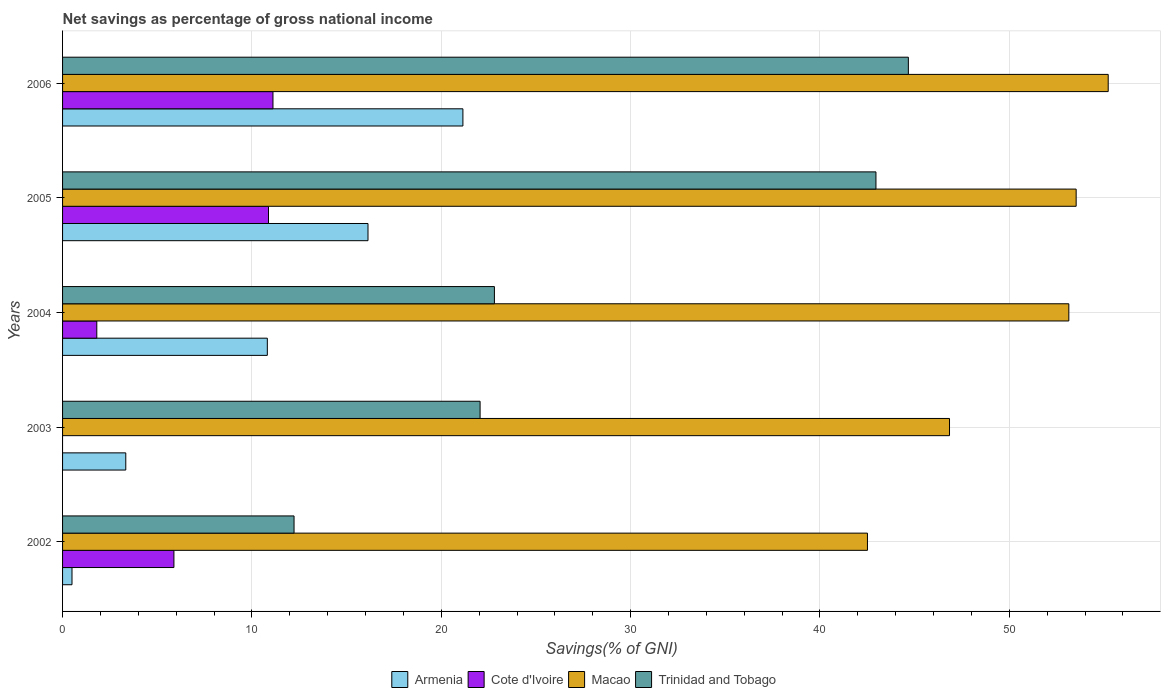How many different coloured bars are there?
Your answer should be compact. 4. How many groups of bars are there?
Provide a succinct answer. 5. Are the number of bars on each tick of the Y-axis equal?
Your answer should be very brief. No. What is the total savings in Cote d'Ivoire in 2002?
Ensure brevity in your answer.  5.88. Across all years, what is the maximum total savings in Cote d'Ivoire?
Your answer should be compact. 11.11. Across all years, what is the minimum total savings in Macao?
Ensure brevity in your answer.  42.51. In which year was the total savings in Armenia maximum?
Your response must be concise. 2006. What is the total total savings in Macao in the graph?
Ensure brevity in your answer.  251.24. What is the difference between the total savings in Armenia in 2005 and that in 2006?
Your answer should be very brief. -5.01. What is the difference between the total savings in Trinidad and Tobago in 2006 and the total savings in Armenia in 2002?
Your response must be concise. 44.17. What is the average total savings in Cote d'Ivoire per year?
Your response must be concise. 5.94. In the year 2005, what is the difference between the total savings in Armenia and total savings in Cote d'Ivoire?
Ensure brevity in your answer.  5.25. In how many years, is the total savings in Macao greater than 48 %?
Keep it short and to the point. 3. What is the ratio of the total savings in Armenia in 2002 to that in 2006?
Ensure brevity in your answer.  0.02. What is the difference between the highest and the second highest total savings in Cote d'Ivoire?
Keep it short and to the point. 0.24. What is the difference between the highest and the lowest total savings in Trinidad and Tobago?
Offer a very short reply. 32.44. Is the sum of the total savings in Macao in 2003 and 2004 greater than the maximum total savings in Cote d'Ivoire across all years?
Make the answer very short. Yes. How many years are there in the graph?
Provide a succinct answer. 5. What is the difference between two consecutive major ticks on the X-axis?
Offer a very short reply. 10. Are the values on the major ticks of X-axis written in scientific E-notation?
Provide a succinct answer. No. Does the graph contain any zero values?
Your answer should be very brief. Yes. Does the graph contain grids?
Your response must be concise. Yes. How many legend labels are there?
Your answer should be compact. 4. How are the legend labels stacked?
Your answer should be compact. Horizontal. What is the title of the graph?
Your answer should be very brief. Net savings as percentage of gross national income. What is the label or title of the X-axis?
Your answer should be compact. Savings(% of GNI). What is the label or title of the Y-axis?
Offer a terse response. Years. What is the Savings(% of GNI) of Armenia in 2002?
Your answer should be compact. 0.5. What is the Savings(% of GNI) of Cote d'Ivoire in 2002?
Offer a terse response. 5.88. What is the Savings(% of GNI) of Macao in 2002?
Offer a terse response. 42.51. What is the Savings(% of GNI) in Trinidad and Tobago in 2002?
Your answer should be very brief. 12.22. What is the Savings(% of GNI) in Armenia in 2003?
Make the answer very short. 3.34. What is the Savings(% of GNI) of Macao in 2003?
Give a very brief answer. 46.84. What is the Savings(% of GNI) of Trinidad and Tobago in 2003?
Your answer should be very brief. 22.05. What is the Savings(% of GNI) of Armenia in 2004?
Ensure brevity in your answer.  10.81. What is the Savings(% of GNI) of Cote d'Ivoire in 2004?
Give a very brief answer. 1.81. What is the Savings(% of GNI) of Macao in 2004?
Provide a succinct answer. 53.14. What is the Savings(% of GNI) in Trinidad and Tobago in 2004?
Provide a short and direct response. 22.81. What is the Savings(% of GNI) of Armenia in 2005?
Provide a succinct answer. 16.13. What is the Savings(% of GNI) of Cote d'Ivoire in 2005?
Offer a terse response. 10.88. What is the Savings(% of GNI) in Macao in 2005?
Ensure brevity in your answer.  53.53. What is the Savings(% of GNI) in Trinidad and Tobago in 2005?
Provide a short and direct response. 42.96. What is the Savings(% of GNI) in Armenia in 2006?
Keep it short and to the point. 21.14. What is the Savings(% of GNI) in Cote d'Ivoire in 2006?
Provide a short and direct response. 11.11. What is the Savings(% of GNI) in Macao in 2006?
Provide a succinct answer. 55.22. What is the Savings(% of GNI) of Trinidad and Tobago in 2006?
Give a very brief answer. 44.67. Across all years, what is the maximum Savings(% of GNI) in Armenia?
Offer a terse response. 21.14. Across all years, what is the maximum Savings(% of GNI) of Cote d'Ivoire?
Provide a short and direct response. 11.11. Across all years, what is the maximum Savings(% of GNI) of Macao?
Your response must be concise. 55.22. Across all years, what is the maximum Savings(% of GNI) of Trinidad and Tobago?
Your answer should be compact. 44.67. Across all years, what is the minimum Savings(% of GNI) of Armenia?
Offer a very short reply. 0.5. Across all years, what is the minimum Savings(% of GNI) in Cote d'Ivoire?
Provide a short and direct response. 0. Across all years, what is the minimum Savings(% of GNI) in Macao?
Provide a succinct answer. 42.51. Across all years, what is the minimum Savings(% of GNI) in Trinidad and Tobago?
Give a very brief answer. 12.22. What is the total Savings(% of GNI) of Armenia in the graph?
Provide a succinct answer. 51.92. What is the total Savings(% of GNI) in Cote d'Ivoire in the graph?
Your answer should be very brief. 29.68. What is the total Savings(% of GNI) in Macao in the graph?
Offer a terse response. 251.24. What is the total Savings(% of GNI) of Trinidad and Tobago in the graph?
Your response must be concise. 144.7. What is the difference between the Savings(% of GNI) of Armenia in 2002 and that in 2003?
Offer a terse response. -2.84. What is the difference between the Savings(% of GNI) of Macao in 2002 and that in 2003?
Make the answer very short. -4.33. What is the difference between the Savings(% of GNI) of Trinidad and Tobago in 2002 and that in 2003?
Make the answer very short. -9.83. What is the difference between the Savings(% of GNI) of Armenia in 2002 and that in 2004?
Provide a succinct answer. -10.32. What is the difference between the Savings(% of GNI) of Cote d'Ivoire in 2002 and that in 2004?
Provide a succinct answer. 4.07. What is the difference between the Savings(% of GNI) in Macao in 2002 and that in 2004?
Keep it short and to the point. -10.63. What is the difference between the Savings(% of GNI) of Trinidad and Tobago in 2002 and that in 2004?
Your answer should be compact. -10.58. What is the difference between the Savings(% of GNI) in Armenia in 2002 and that in 2005?
Offer a terse response. -15.63. What is the difference between the Savings(% of GNI) in Cote d'Ivoire in 2002 and that in 2005?
Offer a very short reply. -4.99. What is the difference between the Savings(% of GNI) of Macao in 2002 and that in 2005?
Your answer should be very brief. -11.02. What is the difference between the Savings(% of GNI) in Trinidad and Tobago in 2002 and that in 2005?
Your answer should be very brief. -30.73. What is the difference between the Savings(% of GNI) in Armenia in 2002 and that in 2006?
Provide a short and direct response. -20.64. What is the difference between the Savings(% of GNI) of Cote d'Ivoire in 2002 and that in 2006?
Make the answer very short. -5.23. What is the difference between the Savings(% of GNI) of Macao in 2002 and that in 2006?
Offer a very short reply. -12.71. What is the difference between the Savings(% of GNI) of Trinidad and Tobago in 2002 and that in 2006?
Offer a terse response. -32.44. What is the difference between the Savings(% of GNI) in Armenia in 2003 and that in 2004?
Provide a succinct answer. -7.48. What is the difference between the Savings(% of GNI) in Macao in 2003 and that in 2004?
Provide a short and direct response. -6.3. What is the difference between the Savings(% of GNI) of Trinidad and Tobago in 2003 and that in 2004?
Offer a terse response. -0.76. What is the difference between the Savings(% of GNI) of Armenia in 2003 and that in 2005?
Make the answer very short. -12.79. What is the difference between the Savings(% of GNI) in Macao in 2003 and that in 2005?
Your answer should be very brief. -6.69. What is the difference between the Savings(% of GNI) of Trinidad and Tobago in 2003 and that in 2005?
Your answer should be compact. -20.91. What is the difference between the Savings(% of GNI) in Armenia in 2003 and that in 2006?
Your answer should be compact. -17.8. What is the difference between the Savings(% of GNI) of Macao in 2003 and that in 2006?
Your response must be concise. -8.38. What is the difference between the Savings(% of GNI) in Trinidad and Tobago in 2003 and that in 2006?
Your answer should be compact. -22.62. What is the difference between the Savings(% of GNI) in Armenia in 2004 and that in 2005?
Give a very brief answer. -5.32. What is the difference between the Savings(% of GNI) in Cote d'Ivoire in 2004 and that in 2005?
Offer a very short reply. -9.07. What is the difference between the Savings(% of GNI) of Macao in 2004 and that in 2005?
Offer a terse response. -0.39. What is the difference between the Savings(% of GNI) of Trinidad and Tobago in 2004 and that in 2005?
Keep it short and to the point. -20.15. What is the difference between the Savings(% of GNI) of Armenia in 2004 and that in 2006?
Your answer should be compact. -10.33. What is the difference between the Savings(% of GNI) of Cote d'Ivoire in 2004 and that in 2006?
Give a very brief answer. -9.3. What is the difference between the Savings(% of GNI) in Macao in 2004 and that in 2006?
Ensure brevity in your answer.  -2.08. What is the difference between the Savings(% of GNI) in Trinidad and Tobago in 2004 and that in 2006?
Provide a succinct answer. -21.86. What is the difference between the Savings(% of GNI) of Armenia in 2005 and that in 2006?
Your answer should be compact. -5.01. What is the difference between the Savings(% of GNI) in Cote d'Ivoire in 2005 and that in 2006?
Your answer should be compact. -0.24. What is the difference between the Savings(% of GNI) in Macao in 2005 and that in 2006?
Ensure brevity in your answer.  -1.69. What is the difference between the Savings(% of GNI) in Trinidad and Tobago in 2005 and that in 2006?
Your answer should be very brief. -1.71. What is the difference between the Savings(% of GNI) in Armenia in 2002 and the Savings(% of GNI) in Macao in 2003?
Your answer should be very brief. -46.34. What is the difference between the Savings(% of GNI) in Armenia in 2002 and the Savings(% of GNI) in Trinidad and Tobago in 2003?
Make the answer very short. -21.55. What is the difference between the Savings(% of GNI) of Cote d'Ivoire in 2002 and the Savings(% of GNI) of Macao in 2003?
Keep it short and to the point. -40.96. What is the difference between the Savings(% of GNI) in Cote d'Ivoire in 2002 and the Savings(% of GNI) in Trinidad and Tobago in 2003?
Offer a very short reply. -16.17. What is the difference between the Savings(% of GNI) in Macao in 2002 and the Savings(% of GNI) in Trinidad and Tobago in 2003?
Give a very brief answer. 20.46. What is the difference between the Savings(% of GNI) in Armenia in 2002 and the Savings(% of GNI) in Cote d'Ivoire in 2004?
Offer a terse response. -1.31. What is the difference between the Savings(% of GNI) in Armenia in 2002 and the Savings(% of GNI) in Macao in 2004?
Provide a succinct answer. -52.64. What is the difference between the Savings(% of GNI) in Armenia in 2002 and the Savings(% of GNI) in Trinidad and Tobago in 2004?
Your response must be concise. -22.31. What is the difference between the Savings(% of GNI) in Cote d'Ivoire in 2002 and the Savings(% of GNI) in Macao in 2004?
Offer a terse response. -47.26. What is the difference between the Savings(% of GNI) in Cote d'Ivoire in 2002 and the Savings(% of GNI) in Trinidad and Tobago in 2004?
Your answer should be compact. -16.92. What is the difference between the Savings(% of GNI) in Macao in 2002 and the Savings(% of GNI) in Trinidad and Tobago in 2004?
Give a very brief answer. 19.7. What is the difference between the Savings(% of GNI) in Armenia in 2002 and the Savings(% of GNI) in Cote d'Ivoire in 2005?
Provide a succinct answer. -10.38. What is the difference between the Savings(% of GNI) of Armenia in 2002 and the Savings(% of GNI) of Macao in 2005?
Keep it short and to the point. -53.03. What is the difference between the Savings(% of GNI) of Armenia in 2002 and the Savings(% of GNI) of Trinidad and Tobago in 2005?
Provide a short and direct response. -42.46. What is the difference between the Savings(% of GNI) of Cote d'Ivoire in 2002 and the Savings(% of GNI) of Macao in 2005?
Your response must be concise. -47.65. What is the difference between the Savings(% of GNI) in Cote d'Ivoire in 2002 and the Savings(% of GNI) in Trinidad and Tobago in 2005?
Provide a short and direct response. -37.07. What is the difference between the Savings(% of GNI) in Macao in 2002 and the Savings(% of GNI) in Trinidad and Tobago in 2005?
Offer a terse response. -0.45. What is the difference between the Savings(% of GNI) of Armenia in 2002 and the Savings(% of GNI) of Cote d'Ivoire in 2006?
Give a very brief answer. -10.61. What is the difference between the Savings(% of GNI) in Armenia in 2002 and the Savings(% of GNI) in Macao in 2006?
Make the answer very short. -54.72. What is the difference between the Savings(% of GNI) in Armenia in 2002 and the Savings(% of GNI) in Trinidad and Tobago in 2006?
Make the answer very short. -44.17. What is the difference between the Savings(% of GNI) of Cote d'Ivoire in 2002 and the Savings(% of GNI) of Macao in 2006?
Ensure brevity in your answer.  -49.34. What is the difference between the Savings(% of GNI) in Cote d'Ivoire in 2002 and the Savings(% of GNI) in Trinidad and Tobago in 2006?
Offer a very short reply. -38.79. What is the difference between the Savings(% of GNI) in Macao in 2002 and the Savings(% of GNI) in Trinidad and Tobago in 2006?
Make the answer very short. -2.16. What is the difference between the Savings(% of GNI) in Armenia in 2003 and the Savings(% of GNI) in Cote d'Ivoire in 2004?
Offer a terse response. 1.53. What is the difference between the Savings(% of GNI) in Armenia in 2003 and the Savings(% of GNI) in Macao in 2004?
Your response must be concise. -49.8. What is the difference between the Savings(% of GNI) in Armenia in 2003 and the Savings(% of GNI) in Trinidad and Tobago in 2004?
Ensure brevity in your answer.  -19.47. What is the difference between the Savings(% of GNI) of Macao in 2003 and the Savings(% of GNI) of Trinidad and Tobago in 2004?
Ensure brevity in your answer.  24.04. What is the difference between the Savings(% of GNI) of Armenia in 2003 and the Savings(% of GNI) of Cote d'Ivoire in 2005?
Provide a short and direct response. -7.54. What is the difference between the Savings(% of GNI) in Armenia in 2003 and the Savings(% of GNI) in Macao in 2005?
Provide a succinct answer. -50.19. What is the difference between the Savings(% of GNI) of Armenia in 2003 and the Savings(% of GNI) of Trinidad and Tobago in 2005?
Provide a succinct answer. -39.62. What is the difference between the Savings(% of GNI) of Macao in 2003 and the Savings(% of GNI) of Trinidad and Tobago in 2005?
Make the answer very short. 3.89. What is the difference between the Savings(% of GNI) in Armenia in 2003 and the Savings(% of GNI) in Cote d'Ivoire in 2006?
Your answer should be compact. -7.77. What is the difference between the Savings(% of GNI) in Armenia in 2003 and the Savings(% of GNI) in Macao in 2006?
Keep it short and to the point. -51.88. What is the difference between the Savings(% of GNI) of Armenia in 2003 and the Savings(% of GNI) of Trinidad and Tobago in 2006?
Provide a succinct answer. -41.33. What is the difference between the Savings(% of GNI) in Macao in 2003 and the Savings(% of GNI) in Trinidad and Tobago in 2006?
Keep it short and to the point. 2.17. What is the difference between the Savings(% of GNI) in Armenia in 2004 and the Savings(% of GNI) in Cote d'Ivoire in 2005?
Keep it short and to the point. -0.06. What is the difference between the Savings(% of GNI) of Armenia in 2004 and the Savings(% of GNI) of Macao in 2005?
Give a very brief answer. -42.72. What is the difference between the Savings(% of GNI) of Armenia in 2004 and the Savings(% of GNI) of Trinidad and Tobago in 2005?
Keep it short and to the point. -32.14. What is the difference between the Savings(% of GNI) of Cote d'Ivoire in 2004 and the Savings(% of GNI) of Macao in 2005?
Offer a very short reply. -51.72. What is the difference between the Savings(% of GNI) in Cote d'Ivoire in 2004 and the Savings(% of GNI) in Trinidad and Tobago in 2005?
Ensure brevity in your answer.  -41.15. What is the difference between the Savings(% of GNI) in Macao in 2004 and the Savings(% of GNI) in Trinidad and Tobago in 2005?
Make the answer very short. 10.19. What is the difference between the Savings(% of GNI) of Armenia in 2004 and the Savings(% of GNI) of Cote d'Ivoire in 2006?
Give a very brief answer. -0.3. What is the difference between the Savings(% of GNI) of Armenia in 2004 and the Savings(% of GNI) of Macao in 2006?
Offer a very short reply. -44.41. What is the difference between the Savings(% of GNI) in Armenia in 2004 and the Savings(% of GNI) in Trinidad and Tobago in 2006?
Your response must be concise. -33.85. What is the difference between the Savings(% of GNI) of Cote d'Ivoire in 2004 and the Savings(% of GNI) of Macao in 2006?
Make the answer very short. -53.41. What is the difference between the Savings(% of GNI) of Cote d'Ivoire in 2004 and the Savings(% of GNI) of Trinidad and Tobago in 2006?
Provide a succinct answer. -42.86. What is the difference between the Savings(% of GNI) of Macao in 2004 and the Savings(% of GNI) of Trinidad and Tobago in 2006?
Make the answer very short. 8.47. What is the difference between the Savings(% of GNI) in Armenia in 2005 and the Savings(% of GNI) in Cote d'Ivoire in 2006?
Make the answer very short. 5.02. What is the difference between the Savings(% of GNI) in Armenia in 2005 and the Savings(% of GNI) in Macao in 2006?
Provide a short and direct response. -39.09. What is the difference between the Savings(% of GNI) of Armenia in 2005 and the Savings(% of GNI) of Trinidad and Tobago in 2006?
Make the answer very short. -28.54. What is the difference between the Savings(% of GNI) of Cote d'Ivoire in 2005 and the Savings(% of GNI) of Macao in 2006?
Ensure brevity in your answer.  -44.35. What is the difference between the Savings(% of GNI) of Cote d'Ivoire in 2005 and the Savings(% of GNI) of Trinidad and Tobago in 2006?
Provide a short and direct response. -33.79. What is the difference between the Savings(% of GNI) of Macao in 2005 and the Savings(% of GNI) of Trinidad and Tobago in 2006?
Your answer should be very brief. 8.86. What is the average Savings(% of GNI) in Armenia per year?
Make the answer very short. 10.38. What is the average Savings(% of GNI) in Cote d'Ivoire per year?
Your answer should be compact. 5.94. What is the average Savings(% of GNI) of Macao per year?
Offer a terse response. 50.25. What is the average Savings(% of GNI) of Trinidad and Tobago per year?
Your answer should be compact. 28.94. In the year 2002, what is the difference between the Savings(% of GNI) in Armenia and Savings(% of GNI) in Cote d'Ivoire?
Provide a short and direct response. -5.38. In the year 2002, what is the difference between the Savings(% of GNI) in Armenia and Savings(% of GNI) in Macao?
Ensure brevity in your answer.  -42.01. In the year 2002, what is the difference between the Savings(% of GNI) in Armenia and Savings(% of GNI) in Trinidad and Tobago?
Offer a very short reply. -11.73. In the year 2002, what is the difference between the Savings(% of GNI) in Cote d'Ivoire and Savings(% of GNI) in Macao?
Provide a short and direct response. -36.63. In the year 2002, what is the difference between the Savings(% of GNI) in Cote d'Ivoire and Savings(% of GNI) in Trinidad and Tobago?
Your response must be concise. -6.34. In the year 2002, what is the difference between the Savings(% of GNI) in Macao and Savings(% of GNI) in Trinidad and Tobago?
Your response must be concise. 30.28. In the year 2003, what is the difference between the Savings(% of GNI) of Armenia and Savings(% of GNI) of Macao?
Ensure brevity in your answer.  -43.5. In the year 2003, what is the difference between the Savings(% of GNI) in Armenia and Savings(% of GNI) in Trinidad and Tobago?
Offer a terse response. -18.71. In the year 2003, what is the difference between the Savings(% of GNI) in Macao and Savings(% of GNI) in Trinidad and Tobago?
Ensure brevity in your answer.  24.79. In the year 2004, what is the difference between the Savings(% of GNI) of Armenia and Savings(% of GNI) of Cote d'Ivoire?
Ensure brevity in your answer.  9.01. In the year 2004, what is the difference between the Savings(% of GNI) of Armenia and Savings(% of GNI) of Macao?
Provide a succinct answer. -42.33. In the year 2004, what is the difference between the Savings(% of GNI) in Armenia and Savings(% of GNI) in Trinidad and Tobago?
Give a very brief answer. -11.99. In the year 2004, what is the difference between the Savings(% of GNI) of Cote d'Ivoire and Savings(% of GNI) of Macao?
Your response must be concise. -51.33. In the year 2004, what is the difference between the Savings(% of GNI) in Cote d'Ivoire and Savings(% of GNI) in Trinidad and Tobago?
Make the answer very short. -21. In the year 2004, what is the difference between the Savings(% of GNI) of Macao and Savings(% of GNI) of Trinidad and Tobago?
Keep it short and to the point. 30.34. In the year 2005, what is the difference between the Savings(% of GNI) of Armenia and Savings(% of GNI) of Cote d'Ivoire?
Make the answer very short. 5.25. In the year 2005, what is the difference between the Savings(% of GNI) in Armenia and Savings(% of GNI) in Macao?
Give a very brief answer. -37.4. In the year 2005, what is the difference between the Savings(% of GNI) in Armenia and Savings(% of GNI) in Trinidad and Tobago?
Offer a terse response. -26.82. In the year 2005, what is the difference between the Savings(% of GNI) of Cote d'Ivoire and Savings(% of GNI) of Macao?
Keep it short and to the point. -42.65. In the year 2005, what is the difference between the Savings(% of GNI) in Cote d'Ivoire and Savings(% of GNI) in Trinidad and Tobago?
Provide a succinct answer. -32.08. In the year 2005, what is the difference between the Savings(% of GNI) of Macao and Savings(% of GNI) of Trinidad and Tobago?
Give a very brief answer. 10.57. In the year 2006, what is the difference between the Savings(% of GNI) of Armenia and Savings(% of GNI) of Cote d'Ivoire?
Make the answer very short. 10.03. In the year 2006, what is the difference between the Savings(% of GNI) of Armenia and Savings(% of GNI) of Macao?
Ensure brevity in your answer.  -34.08. In the year 2006, what is the difference between the Savings(% of GNI) of Armenia and Savings(% of GNI) of Trinidad and Tobago?
Provide a short and direct response. -23.52. In the year 2006, what is the difference between the Savings(% of GNI) in Cote d'Ivoire and Savings(% of GNI) in Macao?
Offer a very short reply. -44.11. In the year 2006, what is the difference between the Savings(% of GNI) in Cote d'Ivoire and Savings(% of GNI) in Trinidad and Tobago?
Provide a short and direct response. -33.56. In the year 2006, what is the difference between the Savings(% of GNI) of Macao and Savings(% of GNI) of Trinidad and Tobago?
Your response must be concise. 10.55. What is the ratio of the Savings(% of GNI) in Armenia in 2002 to that in 2003?
Offer a terse response. 0.15. What is the ratio of the Savings(% of GNI) of Macao in 2002 to that in 2003?
Offer a very short reply. 0.91. What is the ratio of the Savings(% of GNI) of Trinidad and Tobago in 2002 to that in 2003?
Your answer should be compact. 0.55. What is the ratio of the Savings(% of GNI) of Armenia in 2002 to that in 2004?
Offer a very short reply. 0.05. What is the ratio of the Savings(% of GNI) in Cote d'Ivoire in 2002 to that in 2004?
Your answer should be very brief. 3.25. What is the ratio of the Savings(% of GNI) in Macao in 2002 to that in 2004?
Offer a very short reply. 0.8. What is the ratio of the Savings(% of GNI) of Trinidad and Tobago in 2002 to that in 2004?
Your response must be concise. 0.54. What is the ratio of the Savings(% of GNI) of Armenia in 2002 to that in 2005?
Offer a very short reply. 0.03. What is the ratio of the Savings(% of GNI) in Cote d'Ivoire in 2002 to that in 2005?
Your response must be concise. 0.54. What is the ratio of the Savings(% of GNI) in Macao in 2002 to that in 2005?
Your answer should be compact. 0.79. What is the ratio of the Savings(% of GNI) of Trinidad and Tobago in 2002 to that in 2005?
Make the answer very short. 0.28. What is the ratio of the Savings(% of GNI) of Armenia in 2002 to that in 2006?
Provide a short and direct response. 0.02. What is the ratio of the Savings(% of GNI) in Cote d'Ivoire in 2002 to that in 2006?
Keep it short and to the point. 0.53. What is the ratio of the Savings(% of GNI) of Macao in 2002 to that in 2006?
Make the answer very short. 0.77. What is the ratio of the Savings(% of GNI) in Trinidad and Tobago in 2002 to that in 2006?
Provide a succinct answer. 0.27. What is the ratio of the Savings(% of GNI) of Armenia in 2003 to that in 2004?
Your answer should be compact. 0.31. What is the ratio of the Savings(% of GNI) in Macao in 2003 to that in 2004?
Ensure brevity in your answer.  0.88. What is the ratio of the Savings(% of GNI) of Trinidad and Tobago in 2003 to that in 2004?
Offer a terse response. 0.97. What is the ratio of the Savings(% of GNI) in Armenia in 2003 to that in 2005?
Offer a terse response. 0.21. What is the ratio of the Savings(% of GNI) of Macao in 2003 to that in 2005?
Make the answer very short. 0.88. What is the ratio of the Savings(% of GNI) of Trinidad and Tobago in 2003 to that in 2005?
Offer a terse response. 0.51. What is the ratio of the Savings(% of GNI) in Armenia in 2003 to that in 2006?
Your answer should be very brief. 0.16. What is the ratio of the Savings(% of GNI) of Macao in 2003 to that in 2006?
Offer a very short reply. 0.85. What is the ratio of the Savings(% of GNI) of Trinidad and Tobago in 2003 to that in 2006?
Your response must be concise. 0.49. What is the ratio of the Savings(% of GNI) of Armenia in 2004 to that in 2005?
Provide a succinct answer. 0.67. What is the ratio of the Savings(% of GNI) in Cote d'Ivoire in 2004 to that in 2005?
Make the answer very short. 0.17. What is the ratio of the Savings(% of GNI) in Macao in 2004 to that in 2005?
Make the answer very short. 0.99. What is the ratio of the Savings(% of GNI) in Trinidad and Tobago in 2004 to that in 2005?
Give a very brief answer. 0.53. What is the ratio of the Savings(% of GNI) in Armenia in 2004 to that in 2006?
Provide a short and direct response. 0.51. What is the ratio of the Savings(% of GNI) in Cote d'Ivoire in 2004 to that in 2006?
Ensure brevity in your answer.  0.16. What is the ratio of the Savings(% of GNI) in Macao in 2004 to that in 2006?
Provide a succinct answer. 0.96. What is the ratio of the Savings(% of GNI) in Trinidad and Tobago in 2004 to that in 2006?
Your answer should be compact. 0.51. What is the ratio of the Savings(% of GNI) of Armenia in 2005 to that in 2006?
Your response must be concise. 0.76. What is the ratio of the Savings(% of GNI) of Cote d'Ivoire in 2005 to that in 2006?
Keep it short and to the point. 0.98. What is the ratio of the Savings(% of GNI) of Macao in 2005 to that in 2006?
Offer a terse response. 0.97. What is the ratio of the Savings(% of GNI) in Trinidad and Tobago in 2005 to that in 2006?
Offer a terse response. 0.96. What is the difference between the highest and the second highest Savings(% of GNI) of Armenia?
Provide a short and direct response. 5.01. What is the difference between the highest and the second highest Savings(% of GNI) in Cote d'Ivoire?
Offer a very short reply. 0.24. What is the difference between the highest and the second highest Savings(% of GNI) of Macao?
Your answer should be compact. 1.69. What is the difference between the highest and the second highest Savings(% of GNI) in Trinidad and Tobago?
Provide a short and direct response. 1.71. What is the difference between the highest and the lowest Savings(% of GNI) in Armenia?
Your response must be concise. 20.64. What is the difference between the highest and the lowest Savings(% of GNI) of Cote d'Ivoire?
Provide a succinct answer. 11.11. What is the difference between the highest and the lowest Savings(% of GNI) in Macao?
Give a very brief answer. 12.71. What is the difference between the highest and the lowest Savings(% of GNI) in Trinidad and Tobago?
Your response must be concise. 32.44. 